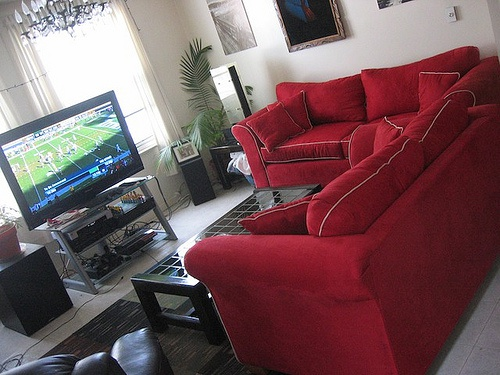Describe the objects in this image and their specific colors. I can see couch in gray, maroon, and brown tones, couch in gray, maroon, brown, and black tones, tv in gray, ivory, lightgreen, and black tones, potted plant in gray, black, darkgray, and darkgreen tones, and chair in gray and black tones in this image. 